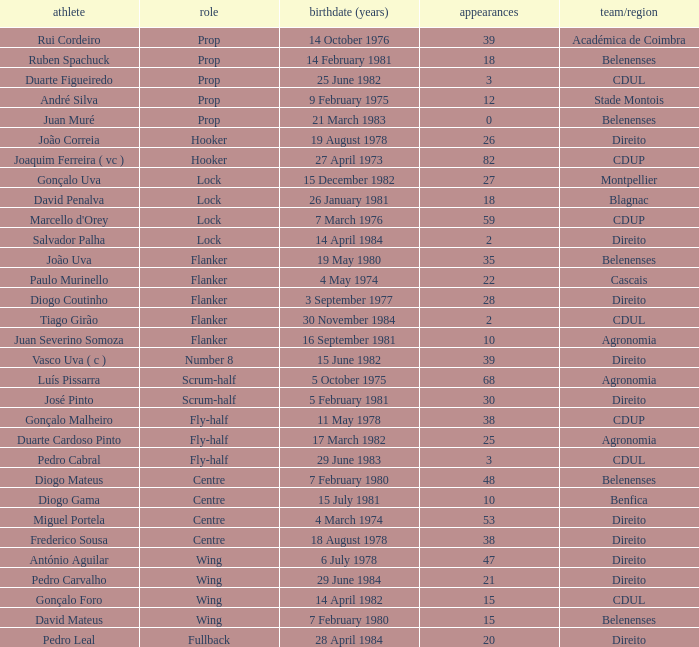How many caps have a Date of Birth (Age) of 15 july 1981? 1.0. 